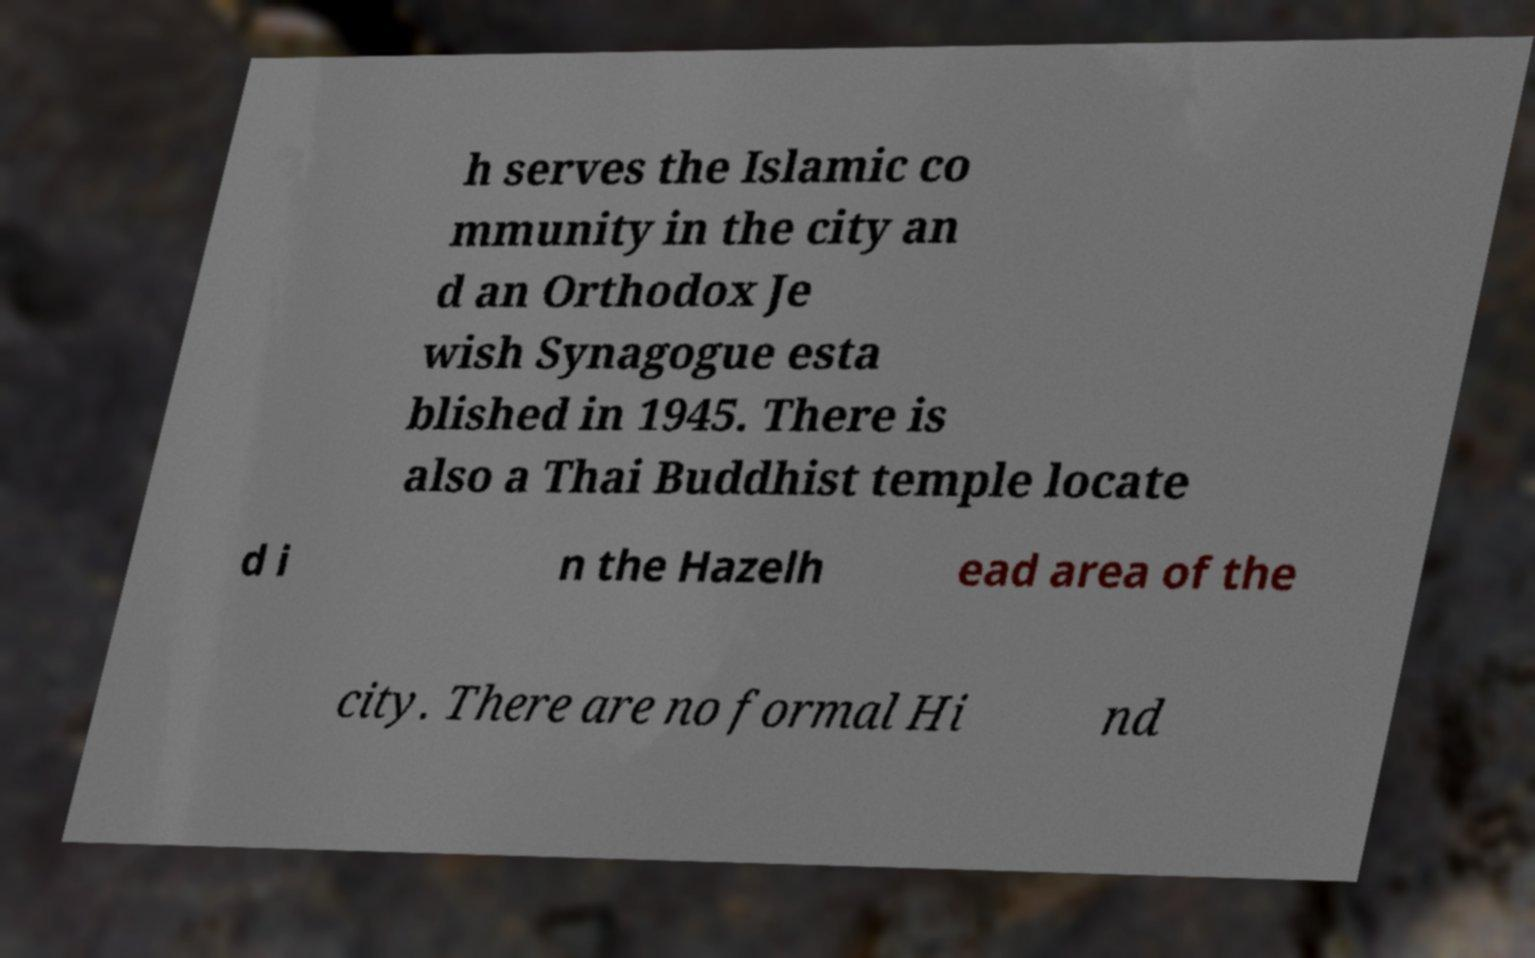There's text embedded in this image that I need extracted. Can you transcribe it verbatim? h serves the Islamic co mmunity in the city an d an Orthodox Je wish Synagogue esta blished in 1945. There is also a Thai Buddhist temple locate d i n the Hazelh ead area of the city. There are no formal Hi nd 